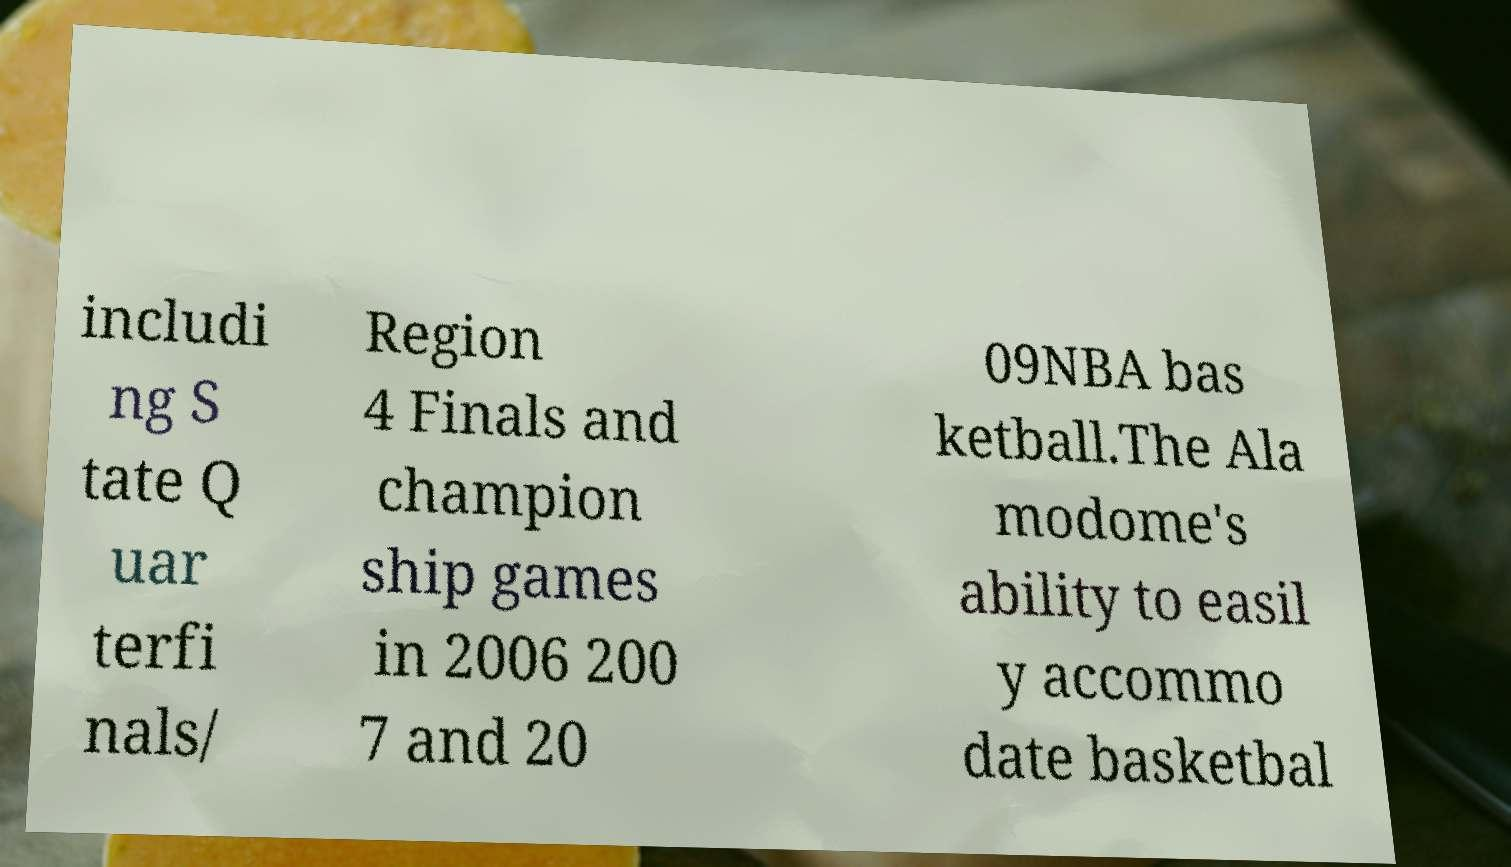Please read and relay the text visible in this image. What does it say? includi ng S tate Q uar terfi nals/ Region 4 Finals and champion ship games in 2006 200 7 and 20 09NBA bas ketball.The Ala modome's ability to easil y accommo date basketbal 